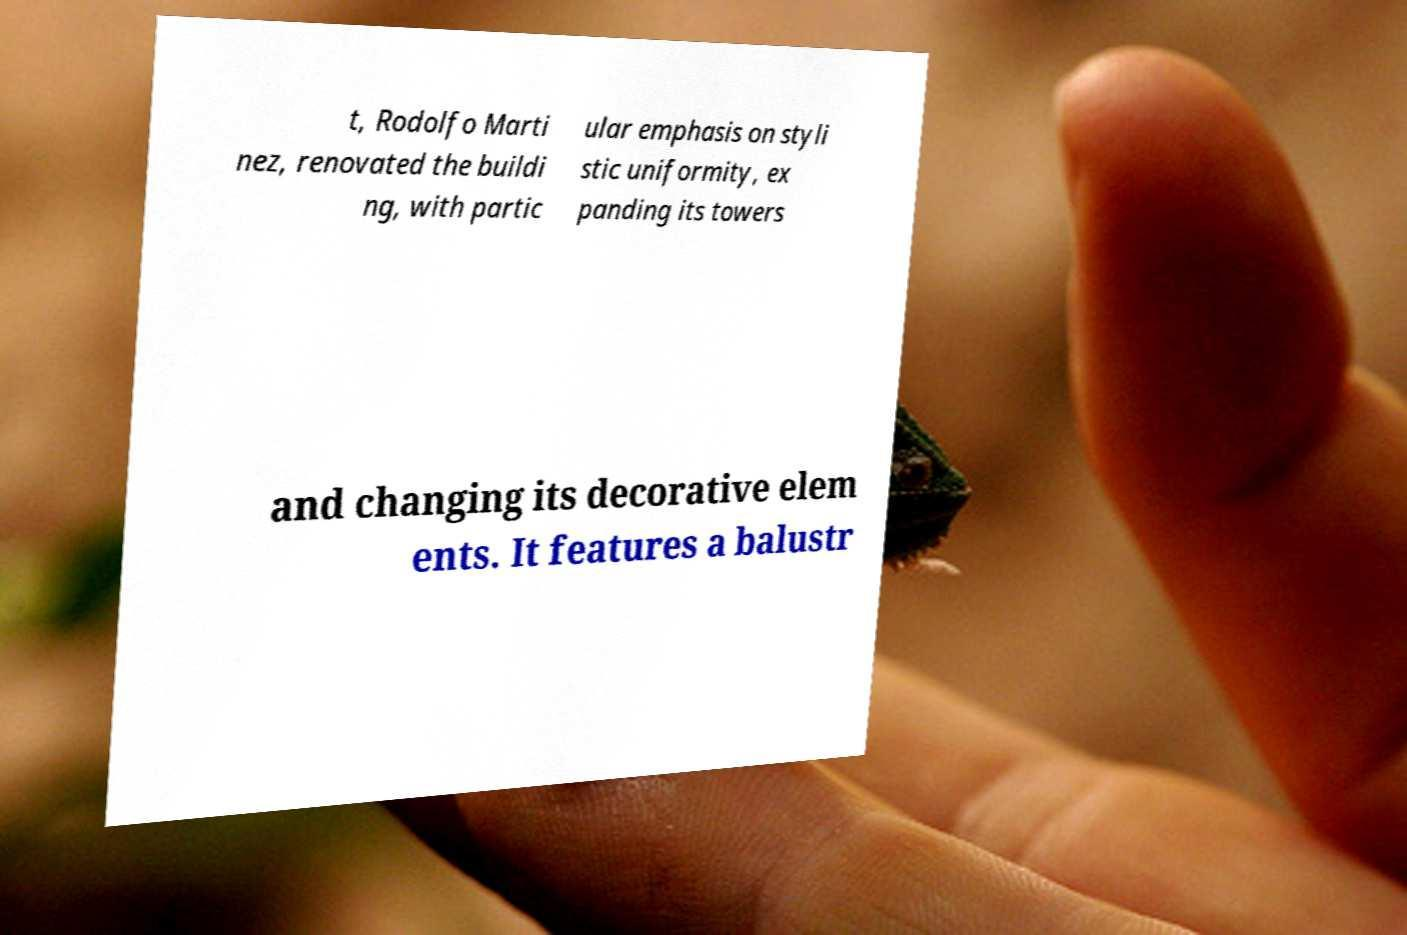Can you accurately transcribe the text from the provided image for me? t, Rodolfo Marti nez, renovated the buildi ng, with partic ular emphasis on styli stic uniformity, ex panding its towers and changing its decorative elem ents. It features a balustr 